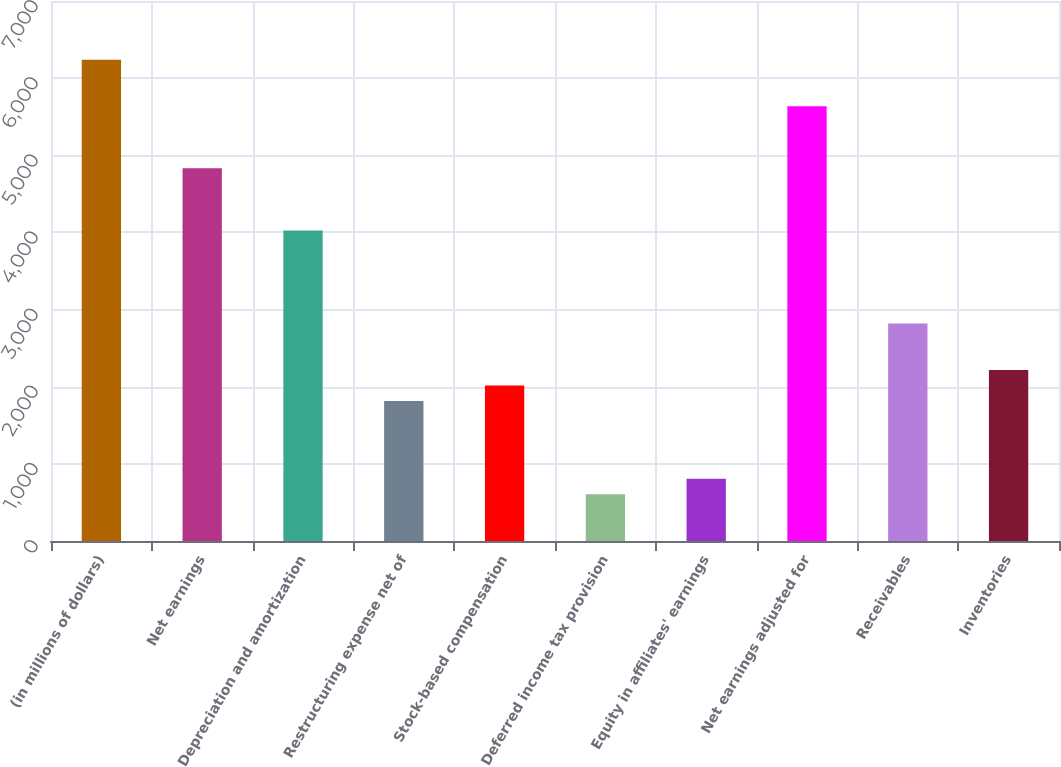Convert chart. <chart><loc_0><loc_0><loc_500><loc_500><bar_chart><fcel>(in millions of dollars)<fcel>Net earnings<fcel>Depreciation and amortization<fcel>Restructuring expense net of<fcel>Stock-based compensation<fcel>Deferred income tax provision<fcel>Equity in affiliates' earnings<fcel>Net earnings adjusted for<fcel>Receivables<fcel>Inventories<nl><fcel>6238.73<fcel>4830.82<fcel>4026.3<fcel>1813.87<fcel>2015<fcel>607.09<fcel>808.22<fcel>5635.34<fcel>2819.52<fcel>2216.13<nl></chart> 